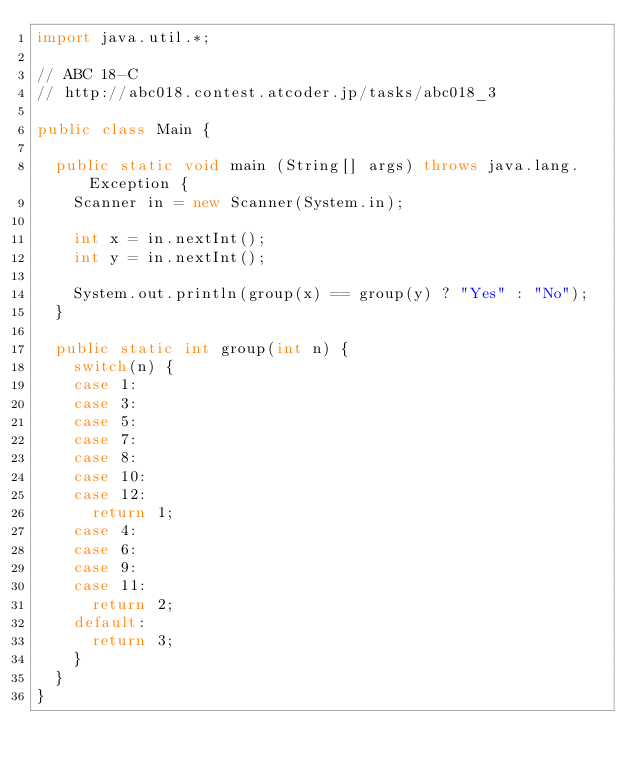<code> <loc_0><loc_0><loc_500><loc_500><_Java_>import java.util.*;

// ABC 18-C
// http://abc018.contest.atcoder.jp/tasks/abc018_3
 
public class Main {

	public static void main (String[] args) throws java.lang.Exception {
		Scanner in = new Scanner(System.in);
		
		int x = in.nextInt();
		int y = in.nextInt();
		
		System.out.println(group(x) == group(y) ? "Yes" : "No");
	}
	
	public static int group(int n) {
		switch(n) {
		case 1:
		case 3:
		case 5:
		case 7:
		case 8:
		case 10:
		case 12:
			return 1;
		case 4:
		case 6:
		case 9:
		case 11:
			return 2;
		default: 
			return 3;
		}
	}
}</code> 